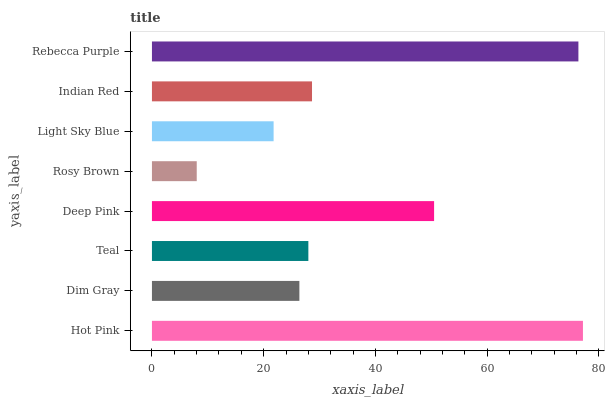Is Rosy Brown the minimum?
Answer yes or no. Yes. Is Hot Pink the maximum?
Answer yes or no. Yes. Is Dim Gray the minimum?
Answer yes or no. No. Is Dim Gray the maximum?
Answer yes or no. No. Is Hot Pink greater than Dim Gray?
Answer yes or no. Yes. Is Dim Gray less than Hot Pink?
Answer yes or no. Yes. Is Dim Gray greater than Hot Pink?
Answer yes or no. No. Is Hot Pink less than Dim Gray?
Answer yes or no. No. Is Indian Red the high median?
Answer yes or no. Yes. Is Teal the low median?
Answer yes or no. Yes. Is Teal the high median?
Answer yes or no. No. Is Rosy Brown the low median?
Answer yes or no. No. 